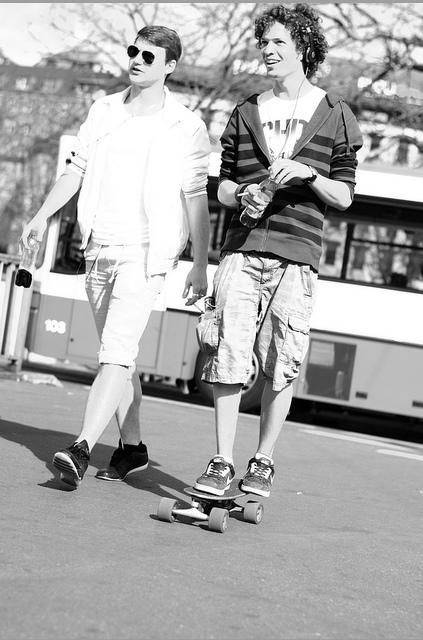Is that a guy on the right?
Concise answer only. Yes. Is she comfortable on her skateboard?
Answer briefly. Yes. Is the person on the left wearing sunglasses?
Give a very brief answer. Yes. 